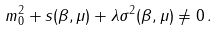<formula> <loc_0><loc_0><loc_500><loc_500>m _ { 0 } ^ { 2 } + s ( \beta , \mu ) + \lambda \sigma ^ { 2 } ( \beta , \mu ) \neq 0 \, .</formula> 